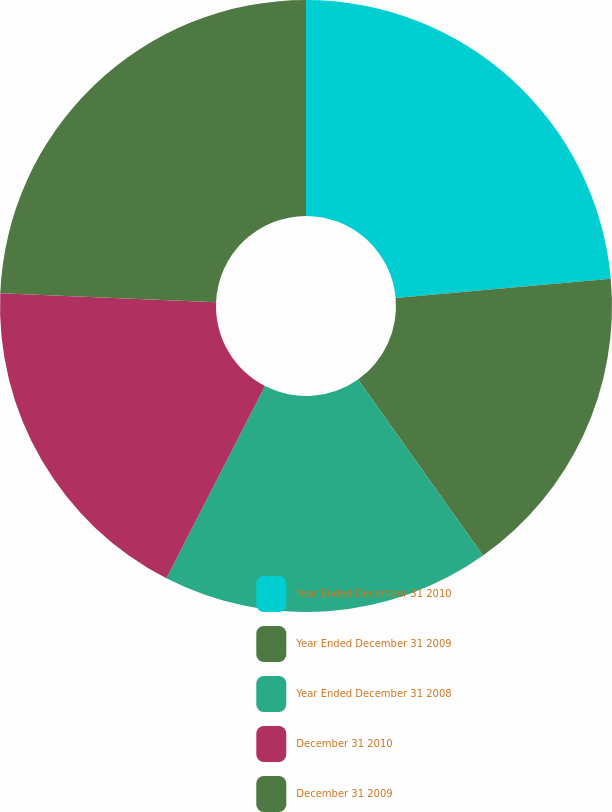<chart> <loc_0><loc_0><loc_500><loc_500><pie_chart><fcel>Year Ended December 31 2010<fcel>Year Ended December 31 2009<fcel>Year Ended December 31 2008<fcel>December 31 2010<fcel>December 31 2009<nl><fcel>23.58%<fcel>16.6%<fcel>17.36%<fcel>18.12%<fcel>24.34%<nl></chart> 